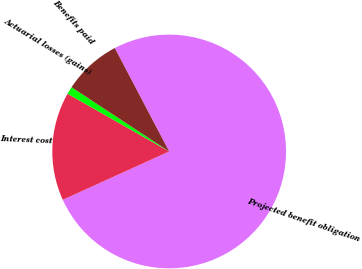Convert chart. <chart><loc_0><loc_0><loc_500><loc_500><pie_chart><fcel>Projected benefit obligation<fcel>Interest cost<fcel>Actuarial losses (gains)<fcel>Benefits paid<nl><fcel>75.92%<fcel>15.01%<fcel>1.04%<fcel>8.03%<nl></chart> 